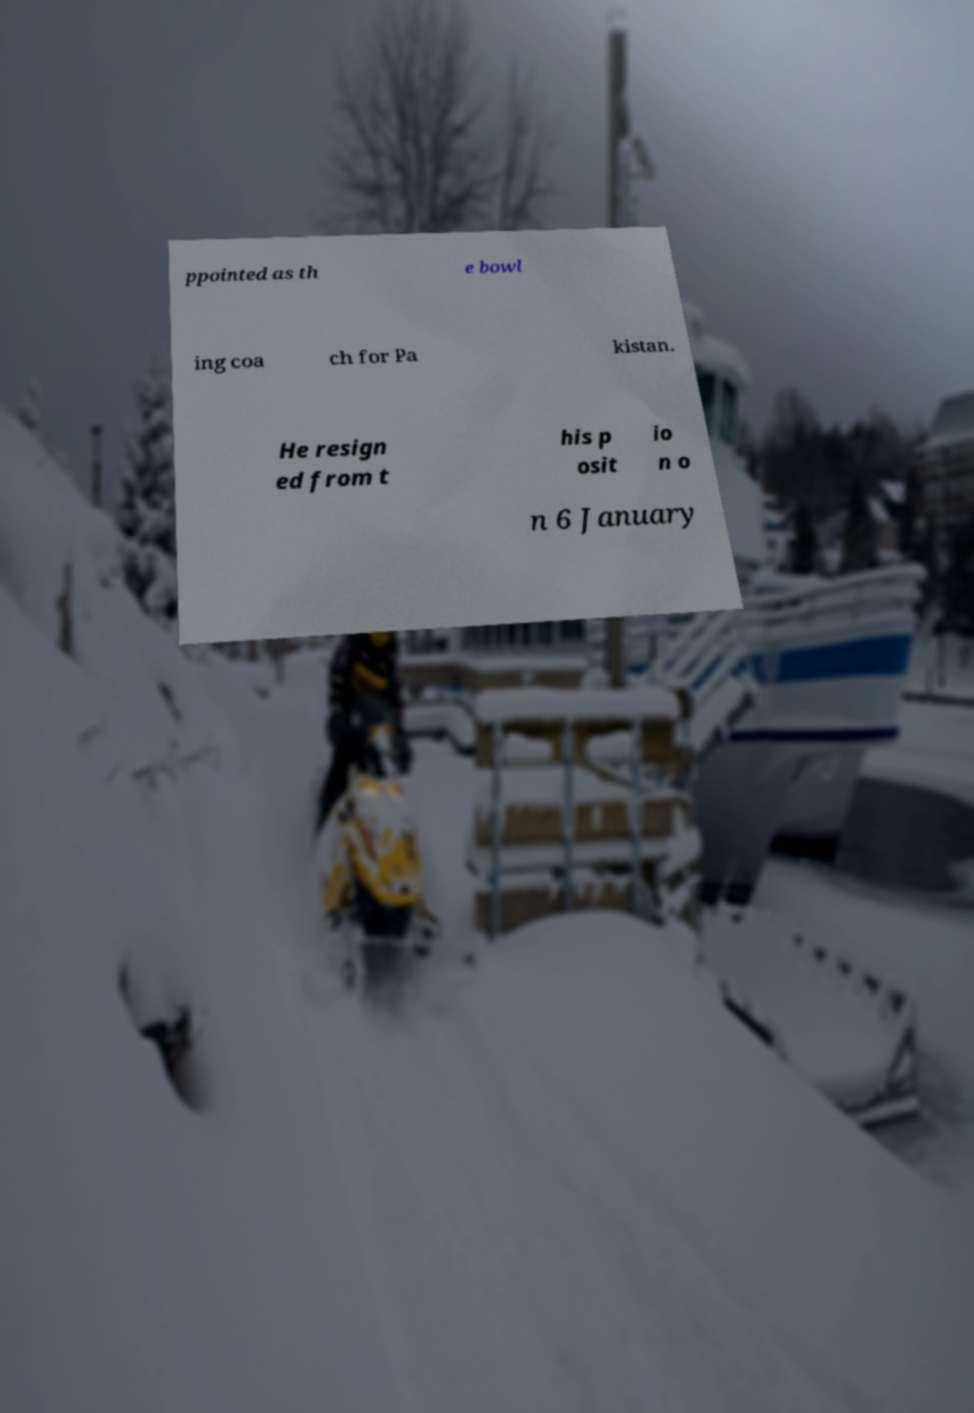I need the written content from this picture converted into text. Can you do that? ppointed as th e bowl ing coa ch for Pa kistan. He resign ed from t his p osit io n o n 6 January 